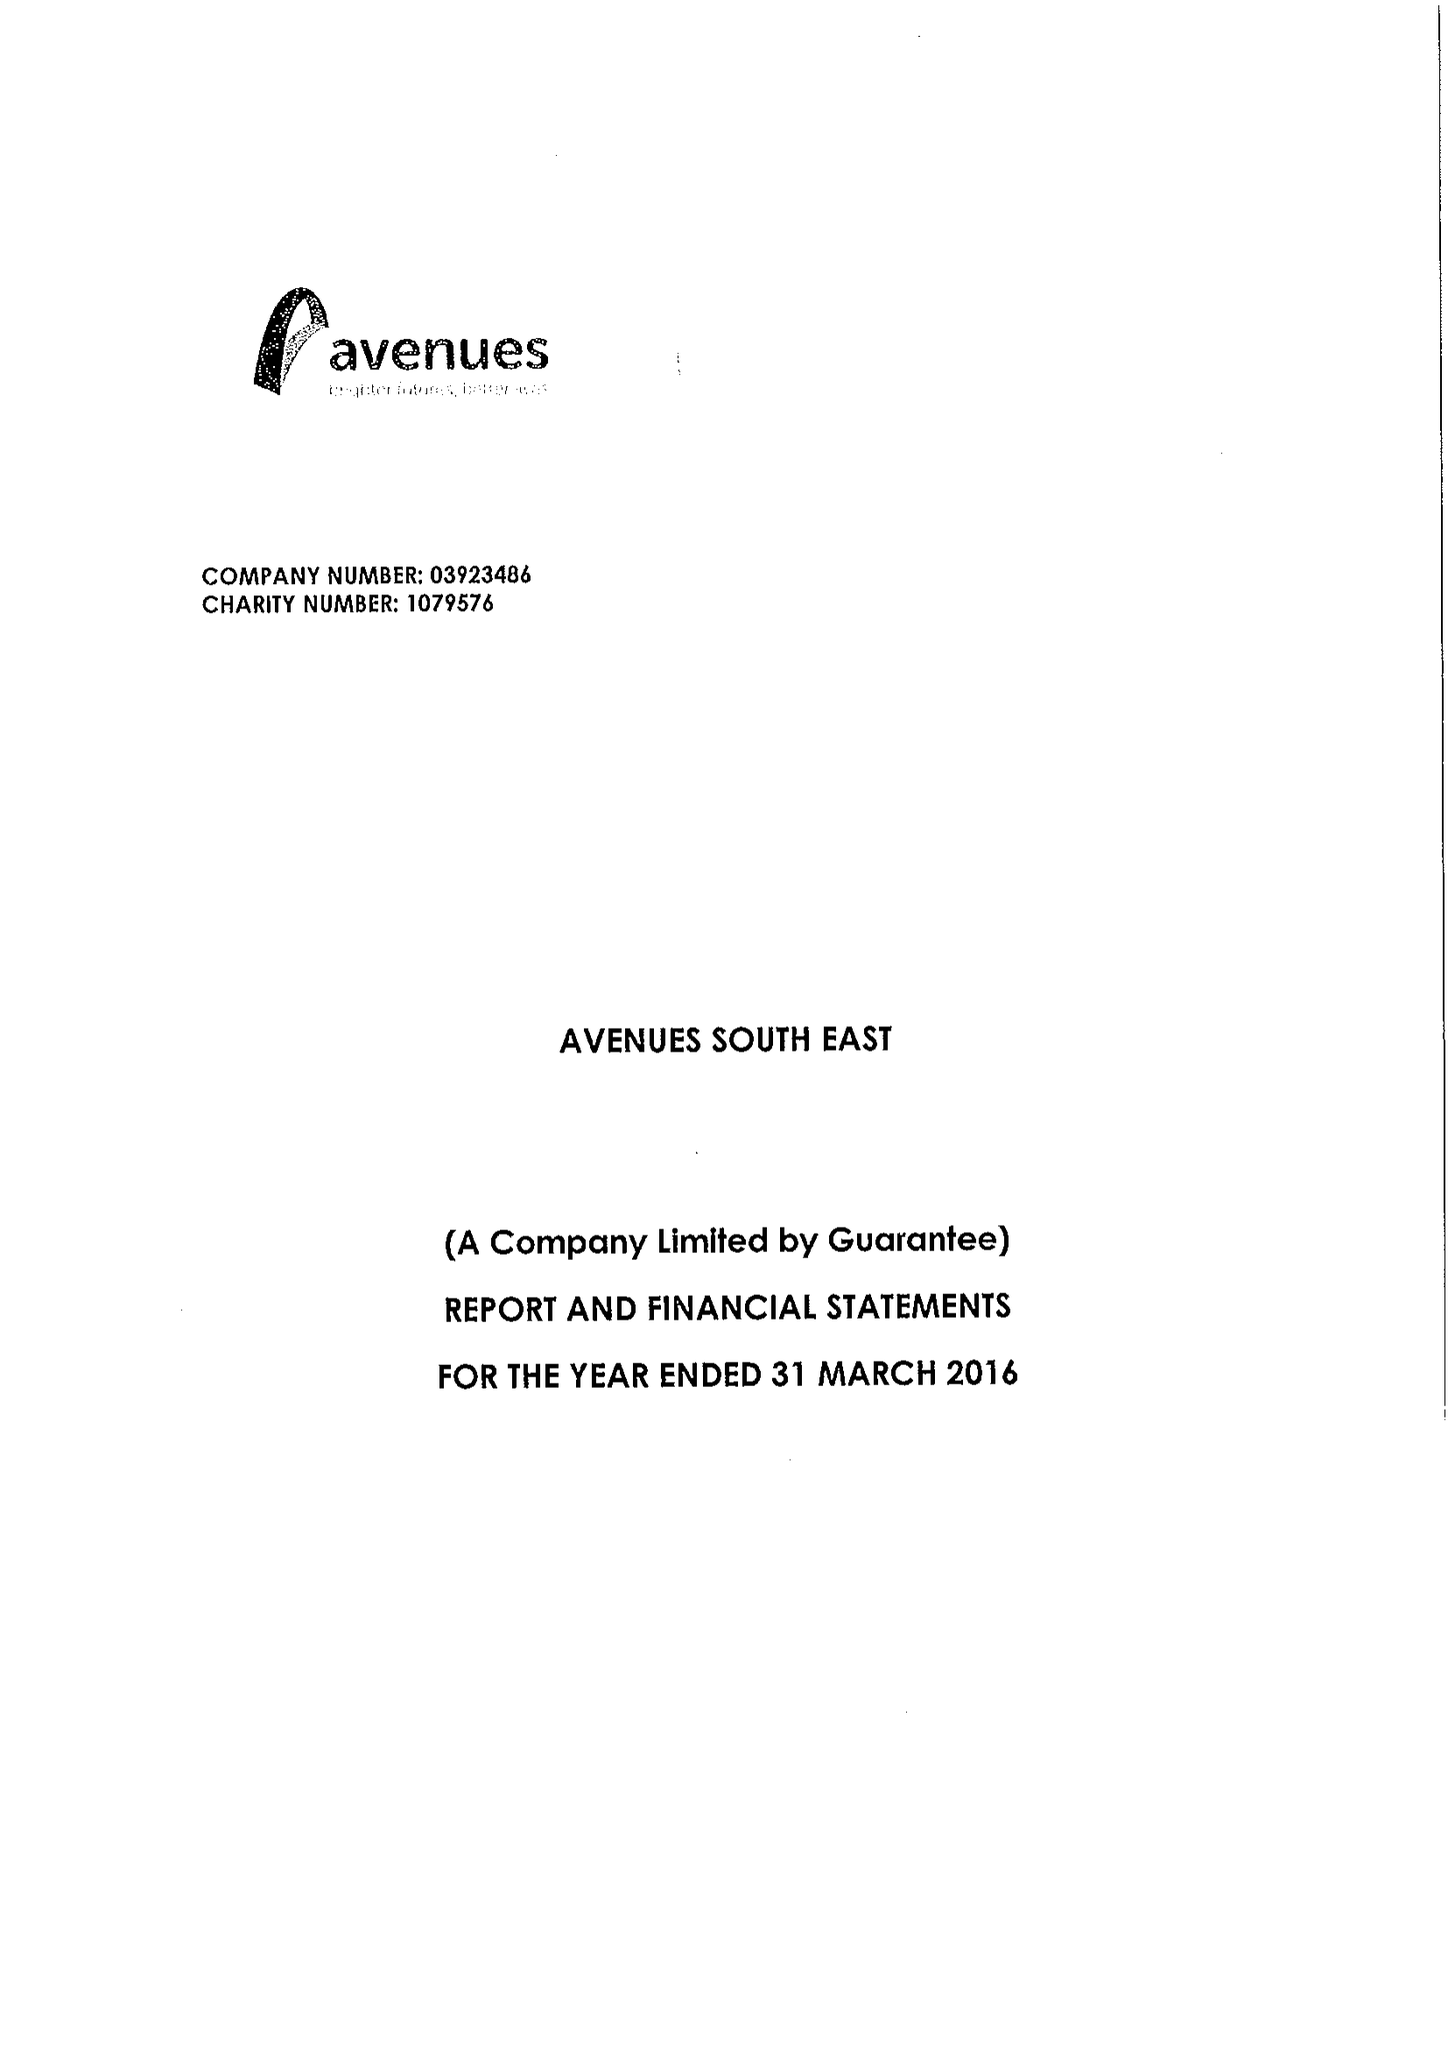What is the value for the charity_name?
Answer the question using a single word or phrase. Avenues South East 